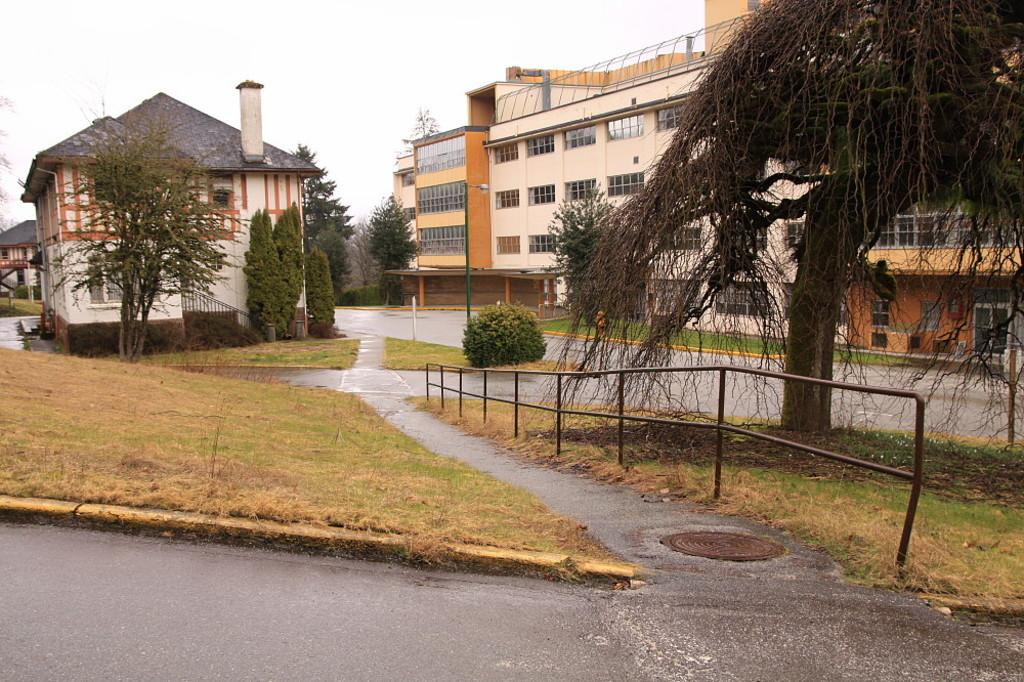What type of structures can be seen in the image? There are buildings in the image. What architectural features are visible on the buildings? There are windows visible on the buildings. What is located in front of the buildings? Trees are present in front of the buildings. What type of barrier is in front of the trees? There is fencing in front of the trees. What type of pathway is visible in the image? There are stairs in the image. What type of lighting fixture is visible in the image? A light-pole is visible in the image. What is the color of the sky in the image? The sky appears to be white in color. What type of vegetable is being used as a treatment for the trees in the image? There is no vegetable or treatment for the trees present in the image. What is located at the back of the buildings in the image? The provided facts do not mention anything about the back of the buildings, so we cannot answer this question definitively. 